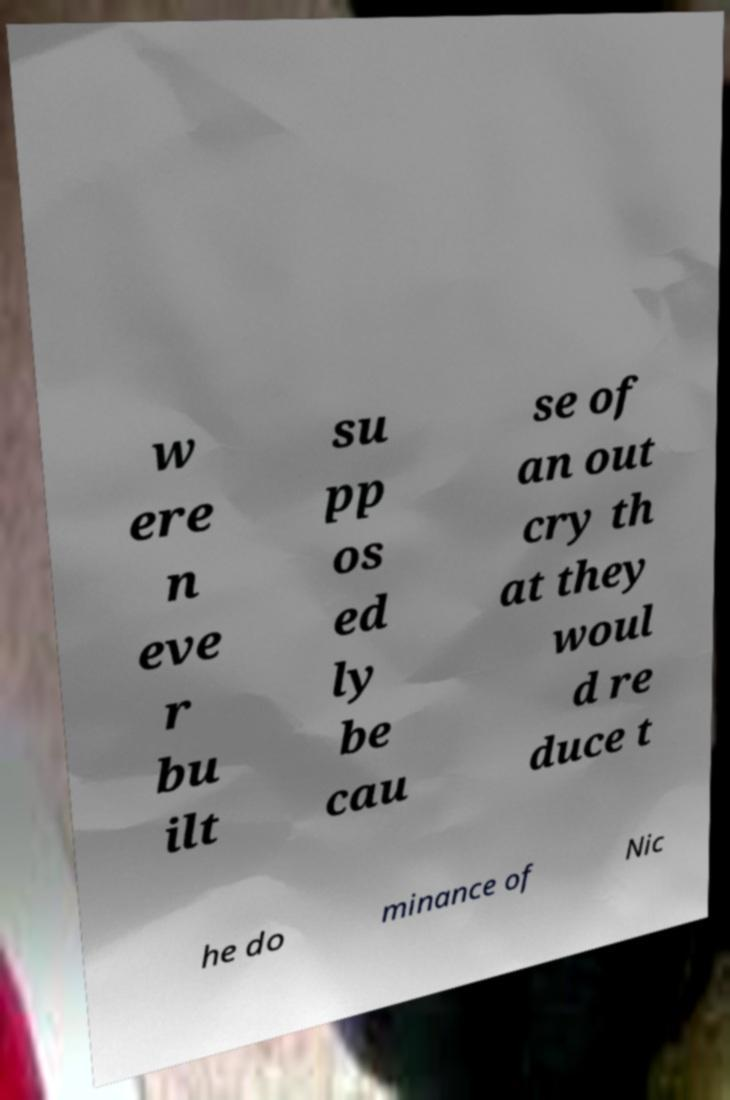Please identify and transcribe the text found in this image. w ere n eve r bu ilt su pp os ed ly be cau se of an out cry th at they woul d re duce t he do minance of Nic 